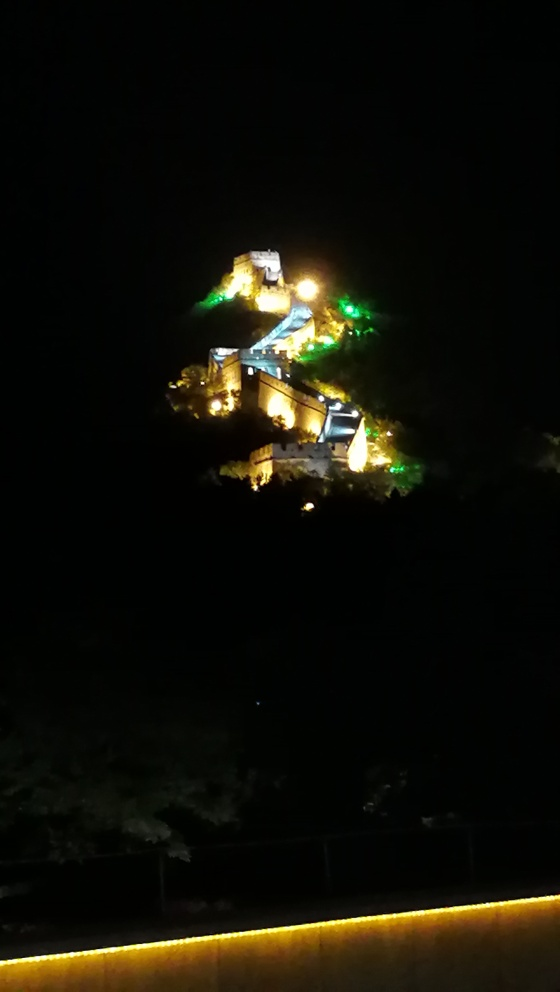Can you describe what is shown in this nighttime photograph? The image captures an illuminated structure atop a hill or mountain, which is visible against a dark sky. The lights seem to outline a path or wall winding up to the summit, suggesting that it could be a historic fortress or castle. The warm lighting gives the scene an enchanting and majestic atmosphere, despite the low visibility. What type of structure do you think this is, and what might its purpose be? Considering the elevation and the manner in which the structure has been lit, it resembles a historical site, possibly a protective fortress, castle, or a temple complex. Its purpose would historically have been defensive or religious, serving as a lookout or sanctuary with its strategic overview. Nowadays, it likely serves as a cultural monument and tourist attraction. 